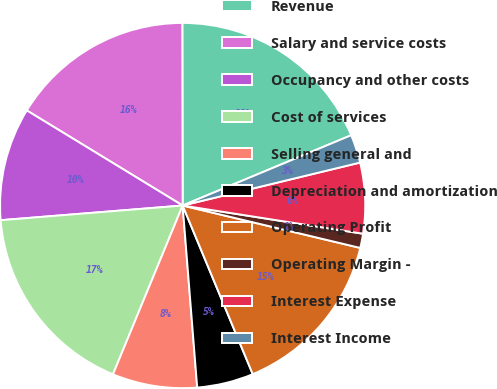Convert chart. <chart><loc_0><loc_0><loc_500><loc_500><pie_chart><fcel>Revenue<fcel>Salary and service costs<fcel>Occupancy and other costs<fcel>Cost of services<fcel>Selling general and<fcel>Depreciation and amortization<fcel>Operating Profit<fcel>Operating Margin -<fcel>Interest Expense<fcel>Interest Income<nl><fcel>18.74%<fcel>16.25%<fcel>10.0%<fcel>17.49%<fcel>7.5%<fcel>5.0%<fcel>15.0%<fcel>1.26%<fcel>6.25%<fcel>2.51%<nl></chart> 